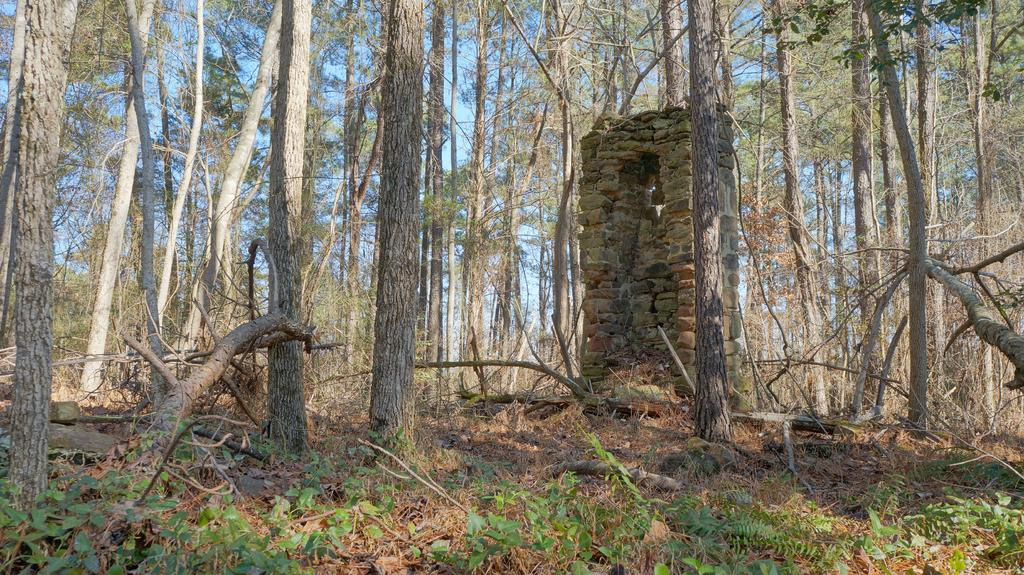What is located in the center of the image? There is a stone wall and a group of trees in the center of the image. What can be seen in the sky in the image? The sky is visible in the image. What type of vegetation is present at the bottom of the image? There are plants at the bottom of the image. How many chickens are sitting on the pump in the image? There are no chickens or pumps present in the image. What type of board is being used to support the plants at the bottom of the image? There is no board present in the image; the plants are directly on the ground. 